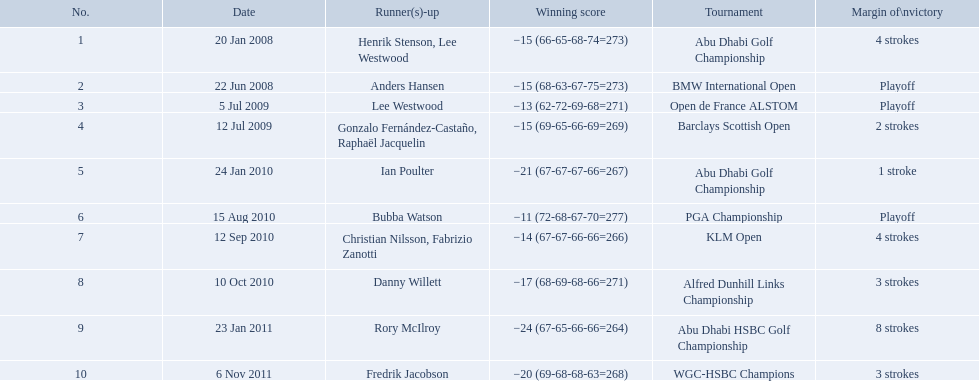What were the margins of victories of the tournaments? 4 strokes, Playoff, Playoff, 2 strokes, 1 stroke, Playoff, 4 strokes, 3 strokes, 8 strokes, 3 strokes. Of these, what was the margin of victory of the klm and the barklay 2 strokes, 4 strokes. What were the difference between these? 2 strokes. 